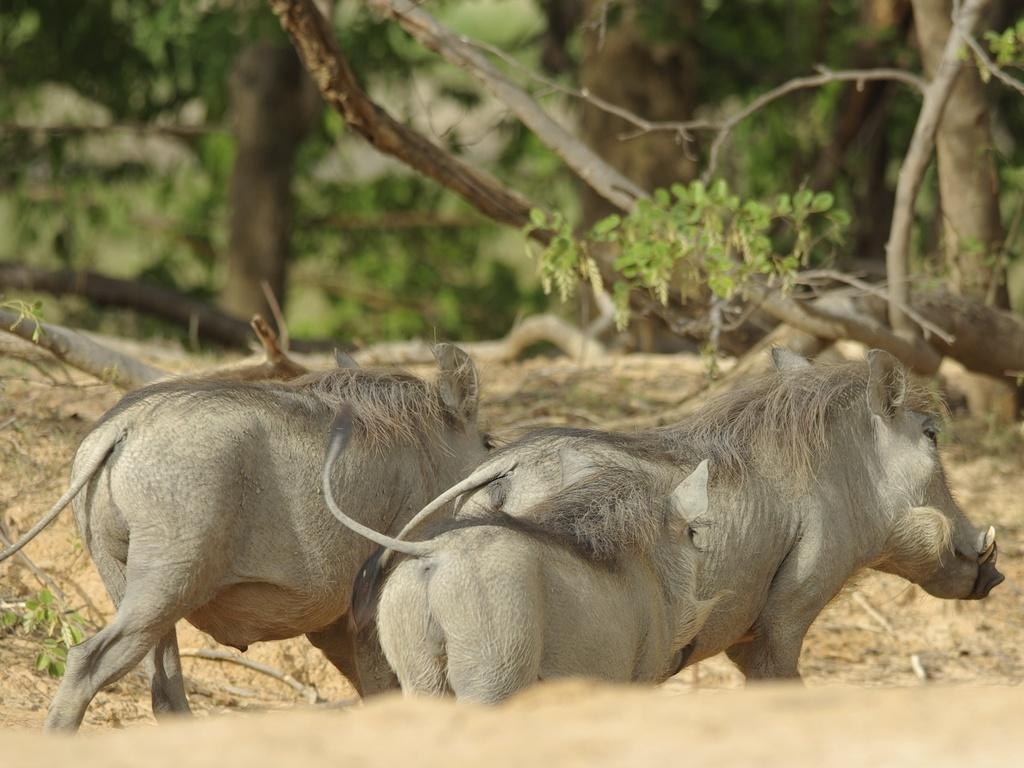How many animals are present in the image? There are two animals in the image. What colors are the animals? The animals are in grey and black colors. What can be seen in the background of the image? There are trees, sand, and sticks visible in the background. What type of thunder can be heard in the image? There is no sound, including thunder, present in the image, as it is a still picture. 